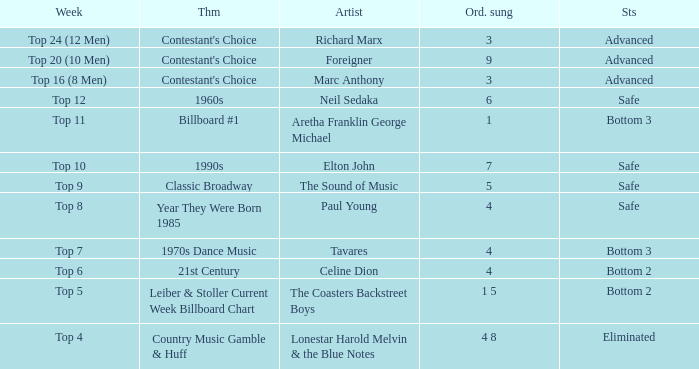What order was the performance of a Richard Marx song? 3.0. 